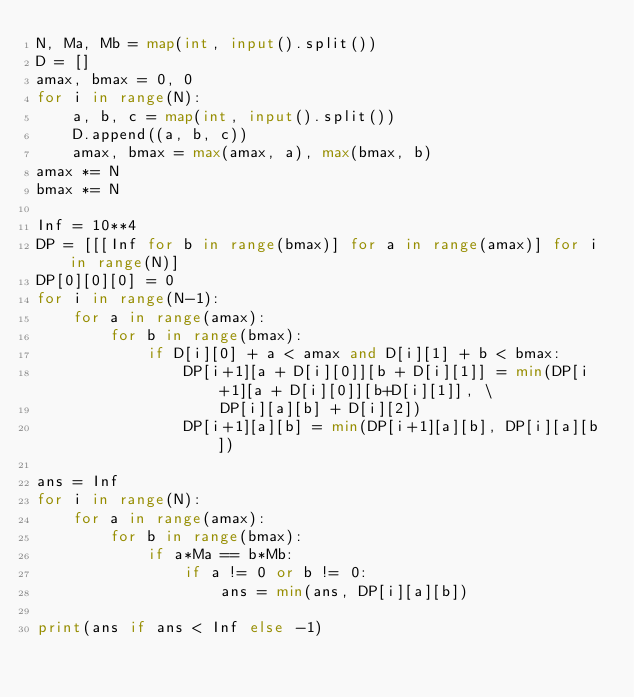<code> <loc_0><loc_0><loc_500><loc_500><_Python_>N, Ma, Mb = map(int, input().split())
D = []
amax, bmax = 0, 0
for i in range(N):
    a, b, c = map(int, input().split())
    D.append((a, b, c))
    amax, bmax = max(amax, a), max(bmax, b)
amax *= N
bmax *= N

Inf = 10**4
DP = [[[Inf for b in range(bmax)] for a in range(amax)] for i in range(N)]
DP[0][0][0] = 0
for i in range(N-1):
    for a in range(amax):
        for b in range(bmax):
            if D[i][0] + a < amax and D[i][1] + b < bmax:
                DP[i+1][a + D[i][0]][b + D[i][1]] = min(DP[i+1][a + D[i][0]][b+D[i][1]], \
                    DP[i][a][b] + D[i][2])
                DP[i+1][a][b] = min(DP[i+1][a][b], DP[i][a][b])

ans = Inf
for i in range(N):
    for a in range(amax):
        for b in range(bmax):
            if a*Ma == b*Mb:
                if a != 0 or b != 0:
                    ans = min(ans, DP[i][a][b])

print(ans if ans < Inf else -1)</code> 